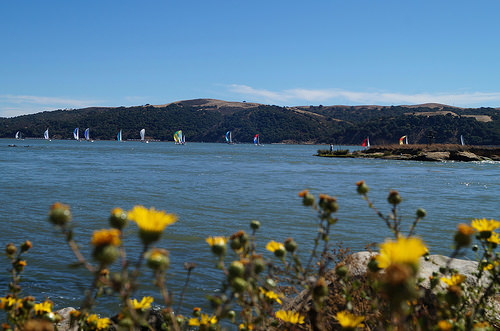<image>
Is there a flower on the water? No. The flower is not positioned on the water. They may be near each other, but the flower is not supported by or resting on top of the water. Is there a dandelion in front of the water? Yes. The dandelion is positioned in front of the water, appearing closer to the camera viewpoint. 